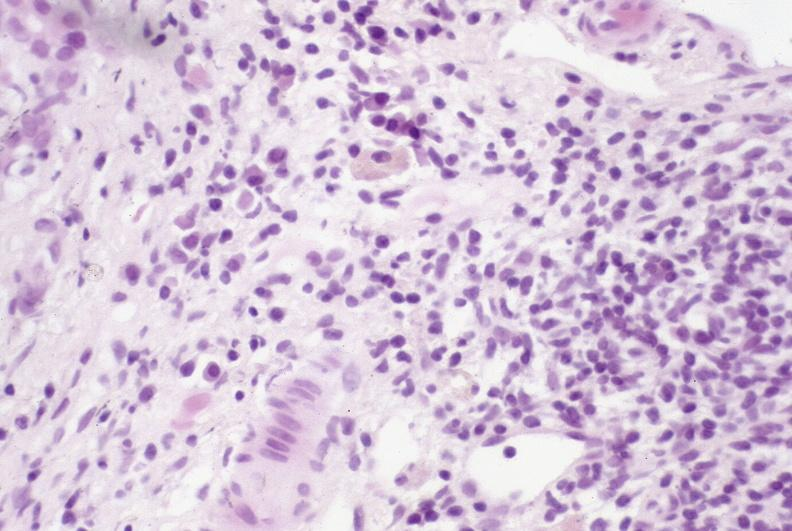what is present?
Answer the question using a single word or phrase. Hepatobiliary 